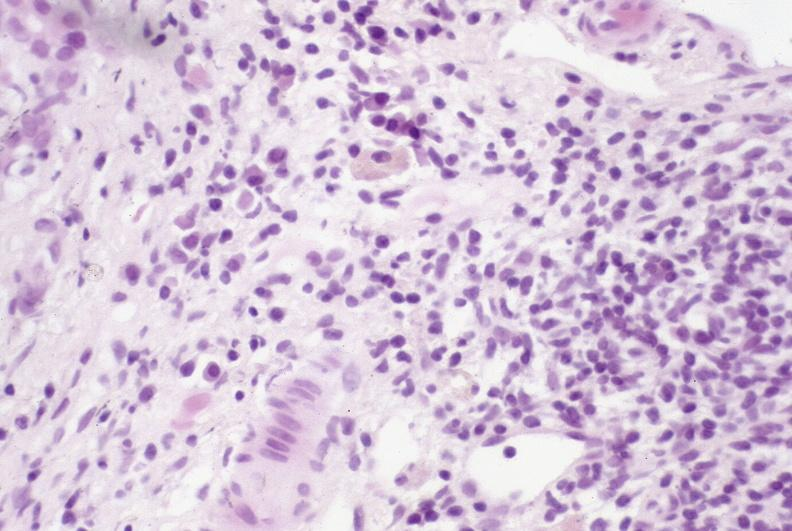what is present?
Answer the question using a single word or phrase. Hepatobiliary 